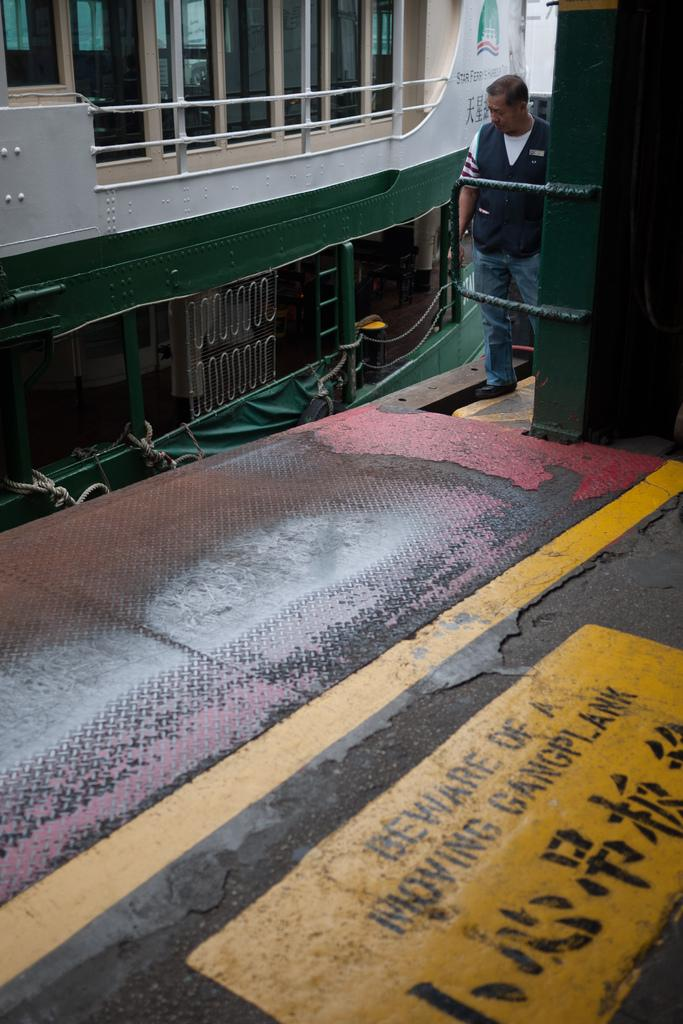What type of structures can be seen in the image? There are buildings in the image. What feature is visible on the buildings? There are windows visible in the image. What object can be seen in the image, separate from the buildings? There is a board in the image. What material is used for the rods in the image? Metal rods are present in the image. Can you describe the person in the image? A person is standing in the image. What time of day was the image likely taken? The image was likely taken during the day, as there is sufficient light to see the details. What type of acoustics can be heard from the donkey in the image? There is no donkey present in the image, so it is not possible to determine the acoustics. 